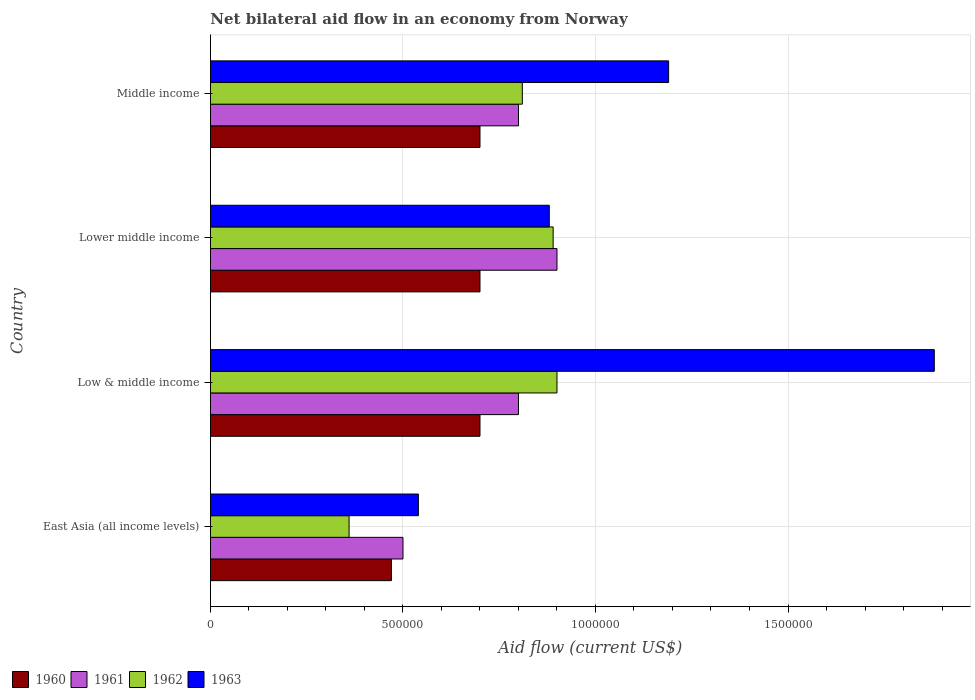Are the number of bars on each tick of the Y-axis equal?
Your answer should be very brief. Yes. How many bars are there on the 4th tick from the bottom?
Your answer should be very brief. 4. In how many cases, is the number of bars for a given country not equal to the number of legend labels?
Your answer should be compact. 0. What is the net bilateral aid flow in 1963 in Middle income?
Provide a succinct answer. 1.19e+06. Across all countries, what is the maximum net bilateral aid flow in 1963?
Keep it short and to the point. 1.88e+06. Across all countries, what is the minimum net bilateral aid flow in 1961?
Keep it short and to the point. 5.00e+05. In which country was the net bilateral aid flow in 1961 maximum?
Provide a short and direct response. Lower middle income. In which country was the net bilateral aid flow in 1963 minimum?
Offer a very short reply. East Asia (all income levels). What is the difference between the net bilateral aid flow in 1963 in East Asia (all income levels) and that in Middle income?
Give a very brief answer. -6.50e+05. What is the average net bilateral aid flow in 1961 per country?
Make the answer very short. 7.50e+05. In how many countries, is the net bilateral aid flow in 1961 greater than 600000 US$?
Offer a very short reply. 3. What is the ratio of the net bilateral aid flow in 1960 in East Asia (all income levels) to that in Lower middle income?
Your answer should be compact. 0.67. Is the net bilateral aid flow in 1960 in Low & middle income less than that in Lower middle income?
Ensure brevity in your answer.  No. Is the difference between the net bilateral aid flow in 1961 in East Asia (all income levels) and Lower middle income greater than the difference between the net bilateral aid flow in 1962 in East Asia (all income levels) and Lower middle income?
Your answer should be very brief. Yes. What is the difference between the highest and the lowest net bilateral aid flow in 1962?
Make the answer very short. 5.40e+05. In how many countries, is the net bilateral aid flow in 1960 greater than the average net bilateral aid flow in 1960 taken over all countries?
Offer a very short reply. 3. Is it the case that in every country, the sum of the net bilateral aid flow in 1961 and net bilateral aid flow in 1963 is greater than the net bilateral aid flow in 1962?
Offer a terse response. Yes. How many bars are there?
Offer a terse response. 16. How many countries are there in the graph?
Ensure brevity in your answer.  4. Are the values on the major ticks of X-axis written in scientific E-notation?
Your answer should be very brief. No. Does the graph contain any zero values?
Ensure brevity in your answer.  No. Does the graph contain grids?
Your answer should be very brief. Yes. What is the title of the graph?
Make the answer very short. Net bilateral aid flow in an economy from Norway. Does "1973" appear as one of the legend labels in the graph?
Offer a terse response. No. What is the label or title of the X-axis?
Provide a succinct answer. Aid flow (current US$). What is the Aid flow (current US$) in 1962 in East Asia (all income levels)?
Offer a very short reply. 3.60e+05. What is the Aid flow (current US$) of 1963 in East Asia (all income levels)?
Ensure brevity in your answer.  5.40e+05. What is the Aid flow (current US$) of 1960 in Low & middle income?
Give a very brief answer. 7.00e+05. What is the Aid flow (current US$) in 1961 in Low & middle income?
Provide a short and direct response. 8.00e+05. What is the Aid flow (current US$) in 1962 in Low & middle income?
Your answer should be very brief. 9.00e+05. What is the Aid flow (current US$) in 1963 in Low & middle income?
Ensure brevity in your answer.  1.88e+06. What is the Aid flow (current US$) in 1961 in Lower middle income?
Offer a terse response. 9.00e+05. What is the Aid flow (current US$) of 1962 in Lower middle income?
Your answer should be compact. 8.90e+05. What is the Aid flow (current US$) in 1963 in Lower middle income?
Provide a succinct answer. 8.80e+05. What is the Aid flow (current US$) in 1960 in Middle income?
Make the answer very short. 7.00e+05. What is the Aid flow (current US$) of 1961 in Middle income?
Give a very brief answer. 8.00e+05. What is the Aid flow (current US$) in 1962 in Middle income?
Ensure brevity in your answer.  8.10e+05. What is the Aid flow (current US$) of 1963 in Middle income?
Give a very brief answer. 1.19e+06. Across all countries, what is the maximum Aid flow (current US$) in 1960?
Ensure brevity in your answer.  7.00e+05. Across all countries, what is the maximum Aid flow (current US$) of 1961?
Offer a terse response. 9.00e+05. Across all countries, what is the maximum Aid flow (current US$) of 1963?
Your answer should be compact. 1.88e+06. Across all countries, what is the minimum Aid flow (current US$) in 1961?
Make the answer very short. 5.00e+05. Across all countries, what is the minimum Aid flow (current US$) of 1963?
Provide a short and direct response. 5.40e+05. What is the total Aid flow (current US$) of 1960 in the graph?
Give a very brief answer. 2.57e+06. What is the total Aid flow (current US$) in 1962 in the graph?
Ensure brevity in your answer.  2.96e+06. What is the total Aid flow (current US$) in 1963 in the graph?
Offer a terse response. 4.49e+06. What is the difference between the Aid flow (current US$) of 1960 in East Asia (all income levels) and that in Low & middle income?
Give a very brief answer. -2.30e+05. What is the difference between the Aid flow (current US$) of 1962 in East Asia (all income levels) and that in Low & middle income?
Keep it short and to the point. -5.40e+05. What is the difference between the Aid flow (current US$) in 1963 in East Asia (all income levels) and that in Low & middle income?
Make the answer very short. -1.34e+06. What is the difference between the Aid flow (current US$) in 1960 in East Asia (all income levels) and that in Lower middle income?
Your answer should be compact. -2.30e+05. What is the difference between the Aid flow (current US$) in 1961 in East Asia (all income levels) and that in Lower middle income?
Give a very brief answer. -4.00e+05. What is the difference between the Aid flow (current US$) in 1962 in East Asia (all income levels) and that in Lower middle income?
Provide a succinct answer. -5.30e+05. What is the difference between the Aid flow (current US$) in 1963 in East Asia (all income levels) and that in Lower middle income?
Keep it short and to the point. -3.40e+05. What is the difference between the Aid flow (current US$) of 1960 in East Asia (all income levels) and that in Middle income?
Your answer should be compact. -2.30e+05. What is the difference between the Aid flow (current US$) of 1962 in East Asia (all income levels) and that in Middle income?
Make the answer very short. -4.50e+05. What is the difference between the Aid flow (current US$) in 1963 in East Asia (all income levels) and that in Middle income?
Offer a terse response. -6.50e+05. What is the difference between the Aid flow (current US$) in 1963 in Low & middle income and that in Lower middle income?
Your answer should be very brief. 1.00e+06. What is the difference between the Aid flow (current US$) in 1960 in Low & middle income and that in Middle income?
Your answer should be very brief. 0. What is the difference between the Aid flow (current US$) of 1963 in Low & middle income and that in Middle income?
Make the answer very short. 6.90e+05. What is the difference between the Aid flow (current US$) of 1960 in Lower middle income and that in Middle income?
Make the answer very short. 0. What is the difference between the Aid flow (current US$) of 1962 in Lower middle income and that in Middle income?
Give a very brief answer. 8.00e+04. What is the difference between the Aid flow (current US$) of 1963 in Lower middle income and that in Middle income?
Provide a short and direct response. -3.10e+05. What is the difference between the Aid flow (current US$) of 1960 in East Asia (all income levels) and the Aid flow (current US$) of 1961 in Low & middle income?
Ensure brevity in your answer.  -3.30e+05. What is the difference between the Aid flow (current US$) in 1960 in East Asia (all income levels) and the Aid flow (current US$) in 1962 in Low & middle income?
Provide a succinct answer. -4.30e+05. What is the difference between the Aid flow (current US$) in 1960 in East Asia (all income levels) and the Aid flow (current US$) in 1963 in Low & middle income?
Ensure brevity in your answer.  -1.41e+06. What is the difference between the Aid flow (current US$) in 1961 in East Asia (all income levels) and the Aid flow (current US$) in 1962 in Low & middle income?
Offer a terse response. -4.00e+05. What is the difference between the Aid flow (current US$) in 1961 in East Asia (all income levels) and the Aid flow (current US$) in 1963 in Low & middle income?
Offer a very short reply. -1.38e+06. What is the difference between the Aid flow (current US$) of 1962 in East Asia (all income levels) and the Aid flow (current US$) of 1963 in Low & middle income?
Your answer should be compact. -1.52e+06. What is the difference between the Aid flow (current US$) in 1960 in East Asia (all income levels) and the Aid flow (current US$) in 1961 in Lower middle income?
Your response must be concise. -4.30e+05. What is the difference between the Aid flow (current US$) in 1960 in East Asia (all income levels) and the Aid flow (current US$) in 1962 in Lower middle income?
Your answer should be compact. -4.20e+05. What is the difference between the Aid flow (current US$) of 1960 in East Asia (all income levels) and the Aid flow (current US$) of 1963 in Lower middle income?
Give a very brief answer. -4.10e+05. What is the difference between the Aid flow (current US$) in 1961 in East Asia (all income levels) and the Aid flow (current US$) in 1962 in Lower middle income?
Your answer should be compact. -3.90e+05. What is the difference between the Aid flow (current US$) in 1961 in East Asia (all income levels) and the Aid flow (current US$) in 1963 in Lower middle income?
Your response must be concise. -3.80e+05. What is the difference between the Aid flow (current US$) in 1962 in East Asia (all income levels) and the Aid flow (current US$) in 1963 in Lower middle income?
Offer a terse response. -5.20e+05. What is the difference between the Aid flow (current US$) in 1960 in East Asia (all income levels) and the Aid flow (current US$) in 1961 in Middle income?
Make the answer very short. -3.30e+05. What is the difference between the Aid flow (current US$) in 1960 in East Asia (all income levels) and the Aid flow (current US$) in 1963 in Middle income?
Offer a terse response. -7.20e+05. What is the difference between the Aid flow (current US$) of 1961 in East Asia (all income levels) and the Aid flow (current US$) of 1962 in Middle income?
Your answer should be very brief. -3.10e+05. What is the difference between the Aid flow (current US$) in 1961 in East Asia (all income levels) and the Aid flow (current US$) in 1963 in Middle income?
Make the answer very short. -6.90e+05. What is the difference between the Aid flow (current US$) in 1962 in East Asia (all income levels) and the Aid flow (current US$) in 1963 in Middle income?
Offer a very short reply. -8.30e+05. What is the difference between the Aid flow (current US$) in 1960 in Low & middle income and the Aid flow (current US$) in 1961 in Lower middle income?
Offer a very short reply. -2.00e+05. What is the difference between the Aid flow (current US$) of 1960 in Low & middle income and the Aid flow (current US$) of 1962 in Lower middle income?
Keep it short and to the point. -1.90e+05. What is the difference between the Aid flow (current US$) in 1961 in Low & middle income and the Aid flow (current US$) in 1962 in Lower middle income?
Make the answer very short. -9.00e+04. What is the difference between the Aid flow (current US$) of 1961 in Low & middle income and the Aid flow (current US$) of 1963 in Lower middle income?
Your response must be concise. -8.00e+04. What is the difference between the Aid flow (current US$) of 1962 in Low & middle income and the Aid flow (current US$) of 1963 in Lower middle income?
Provide a short and direct response. 2.00e+04. What is the difference between the Aid flow (current US$) of 1960 in Low & middle income and the Aid flow (current US$) of 1961 in Middle income?
Keep it short and to the point. -1.00e+05. What is the difference between the Aid flow (current US$) of 1960 in Low & middle income and the Aid flow (current US$) of 1962 in Middle income?
Offer a very short reply. -1.10e+05. What is the difference between the Aid flow (current US$) in 1960 in Low & middle income and the Aid flow (current US$) in 1963 in Middle income?
Ensure brevity in your answer.  -4.90e+05. What is the difference between the Aid flow (current US$) in 1961 in Low & middle income and the Aid flow (current US$) in 1962 in Middle income?
Provide a short and direct response. -10000. What is the difference between the Aid flow (current US$) of 1961 in Low & middle income and the Aid flow (current US$) of 1963 in Middle income?
Offer a terse response. -3.90e+05. What is the difference between the Aid flow (current US$) of 1962 in Low & middle income and the Aid flow (current US$) of 1963 in Middle income?
Keep it short and to the point. -2.90e+05. What is the difference between the Aid flow (current US$) of 1960 in Lower middle income and the Aid flow (current US$) of 1961 in Middle income?
Provide a succinct answer. -1.00e+05. What is the difference between the Aid flow (current US$) of 1960 in Lower middle income and the Aid flow (current US$) of 1963 in Middle income?
Offer a very short reply. -4.90e+05. What is the difference between the Aid flow (current US$) in 1961 in Lower middle income and the Aid flow (current US$) in 1962 in Middle income?
Give a very brief answer. 9.00e+04. What is the average Aid flow (current US$) of 1960 per country?
Make the answer very short. 6.42e+05. What is the average Aid flow (current US$) in 1961 per country?
Offer a very short reply. 7.50e+05. What is the average Aid flow (current US$) in 1962 per country?
Your response must be concise. 7.40e+05. What is the average Aid flow (current US$) in 1963 per country?
Your answer should be very brief. 1.12e+06. What is the difference between the Aid flow (current US$) of 1960 and Aid flow (current US$) of 1961 in East Asia (all income levels)?
Your response must be concise. -3.00e+04. What is the difference between the Aid flow (current US$) in 1961 and Aid flow (current US$) in 1962 in East Asia (all income levels)?
Your response must be concise. 1.40e+05. What is the difference between the Aid flow (current US$) of 1960 and Aid flow (current US$) of 1961 in Low & middle income?
Offer a very short reply. -1.00e+05. What is the difference between the Aid flow (current US$) in 1960 and Aid flow (current US$) in 1962 in Low & middle income?
Provide a short and direct response. -2.00e+05. What is the difference between the Aid flow (current US$) of 1960 and Aid flow (current US$) of 1963 in Low & middle income?
Offer a terse response. -1.18e+06. What is the difference between the Aid flow (current US$) of 1961 and Aid flow (current US$) of 1963 in Low & middle income?
Provide a short and direct response. -1.08e+06. What is the difference between the Aid flow (current US$) of 1962 and Aid flow (current US$) of 1963 in Low & middle income?
Keep it short and to the point. -9.80e+05. What is the difference between the Aid flow (current US$) of 1960 and Aid flow (current US$) of 1962 in Middle income?
Your answer should be very brief. -1.10e+05. What is the difference between the Aid flow (current US$) in 1960 and Aid flow (current US$) in 1963 in Middle income?
Offer a terse response. -4.90e+05. What is the difference between the Aid flow (current US$) of 1961 and Aid flow (current US$) of 1962 in Middle income?
Keep it short and to the point. -10000. What is the difference between the Aid flow (current US$) of 1961 and Aid flow (current US$) of 1963 in Middle income?
Keep it short and to the point. -3.90e+05. What is the difference between the Aid flow (current US$) in 1962 and Aid flow (current US$) in 1963 in Middle income?
Keep it short and to the point. -3.80e+05. What is the ratio of the Aid flow (current US$) in 1960 in East Asia (all income levels) to that in Low & middle income?
Offer a very short reply. 0.67. What is the ratio of the Aid flow (current US$) of 1963 in East Asia (all income levels) to that in Low & middle income?
Make the answer very short. 0.29. What is the ratio of the Aid flow (current US$) of 1960 in East Asia (all income levels) to that in Lower middle income?
Provide a succinct answer. 0.67. What is the ratio of the Aid flow (current US$) of 1961 in East Asia (all income levels) to that in Lower middle income?
Your response must be concise. 0.56. What is the ratio of the Aid flow (current US$) in 1962 in East Asia (all income levels) to that in Lower middle income?
Give a very brief answer. 0.4. What is the ratio of the Aid flow (current US$) in 1963 in East Asia (all income levels) to that in Lower middle income?
Make the answer very short. 0.61. What is the ratio of the Aid flow (current US$) of 1960 in East Asia (all income levels) to that in Middle income?
Your answer should be compact. 0.67. What is the ratio of the Aid flow (current US$) of 1961 in East Asia (all income levels) to that in Middle income?
Make the answer very short. 0.62. What is the ratio of the Aid flow (current US$) in 1962 in East Asia (all income levels) to that in Middle income?
Ensure brevity in your answer.  0.44. What is the ratio of the Aid flow (current US$) of 1963 in East Asia (all income levels) to that in Middle income?
Ensure brevity in your answer.  0.45. What is the ratio of the Aid flow (current US$) of 1961 in Low & middle income to that in Lower middle income?
Offer a terse response. 0.89. What is the ratio of the Aid flow (current US$) of 1962 in Low & middle income to that in Lower middle income?
Provide a short and direct response. 1.01. What is the ratio of the Aid flow (current US$) in 1963 in Low & middle income to that in Lower middle income?
Your answer should be very brief. 2.14. What is the ratio of the Aid flow (current US$) of 1960 in Low & middle income to that in Middle income?
Keep it short and to the point. 1. What is the ratio of the Aid flow (current US$) in 1963 in Low & middle income to that in Middle income?
Your answer should be compact. 1.58. What is the ratio of the Aid flow (current US$) in 1962 in Lower middle income to that in Middle income?
Your answer should be very brief. 1.1. What is the ratio of the Aid flow (current US$) of 1963 in Lower middle income to that in Middle income?
Offer a terse response. 0.74. What is the difference between the highest and the second highest Aid flow (current US$) in 1960?
Your answer should be compact. 0. What is the difference between the highest and the second highest Aid flow (current US$) of 1963?
Offer a terse response. 6.90e+05. What is the difference between the highest and the lowest Aid flow (current US$) in 1961?
Provide a short and direct response. 4.00e+05. What is the difference between the highest and the lowest Aid flow (current US$) in 1962?
Provide a succinct answer. 5.40e+05. What is the difference between the highest and the lowest Aid flow (current US$) of 1963?
Your response must be concise. 1.34e+06. 